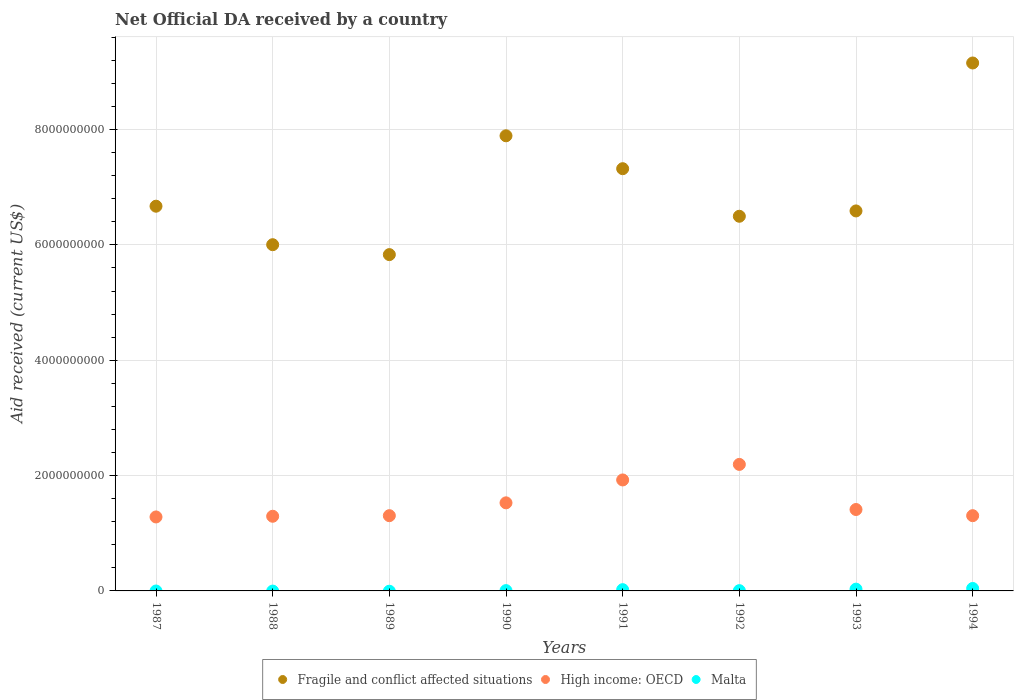What is the net official development assistance aid received in Fragile and conflict affected situations in 1990?
Give a very brief answer. 7.89e+09. Across all years, what is the maximum net official development assistance aid received in Fragile and conflict affected situations?
Offer a terse response. 9.16e+09. Across all years, what is the minimum net official development assistance aid received in Fragile and conflict affected situations?
Your answer should be compact. 5.83e+09. In which year was the net official development assistance aid received in High income: OECD maximum?
Give a very brief answer. 1992. What is the total net official development assistance aid received in Fragile and conflict affected situations in the graph?
Offer a very short reply. 5.60e+1. What is the difference between the net official development assistance aid received in High income: OECD in 1992 and that in 1993?
Offer a terse response. 7.82e+08. What is the difference between the net official development assistance aid received in Fragile and conflict affected situations in 1988 and the net official development assistance aid received in Malta in 1994?
Provide a short and direct response. 5.96e+09. What is the average net official development assistance aid received in Fragile and conflict affected situations per year?
Provide a short and direct response. 7.00e+09. In the year 1992, what is the difference between the net official development assistance aid received in High income: OECD and net official development assistance aid received in Fragile and conflict affected situations?
Give a very brief answer. -4.30e+09. What is the ratio of the net official development assistance aid received in High income: OECD in 1989 to that in 1992?
Ensure brevity in your answer.  0.59. Is the net official development assistance aid received in Fragile and conflict affected situations in 1991 less than that in 1993?
Make the answer very short. No. What is the difference between the highest and the second highest net official development assistance aid received in High income: OECD?
Make the answer very short. 2.70e+08. What is the difference between the highest and the lowest net official development assistance aid received in High income: OECD?
Ensure brevity in your answer.  9.11e+08. Is the sum of the net official development assistance aid received in High income: OECD in 1988 and 1992 greater than the maximum net official development assistance aid received in Fragile and conflict affected situations across all years?
Your response must be concise. No. Does the net official development assistance aid received in Fragile and conflict affected situations monotonically increase over the years?
Your answer should be very brief. No. How many years are there in the graph?
Your answer should be very brief. 8. What is the difference between two consecutive major ticks on the Y-axis?
Make the answer very short. 2.00e+09. Are the values on the major ticks of Y-axis written in scientific E-notation?
Make the answer very short. No. Does the graph contain any zero values?
Your response must be concise. Yes. How many legend labels are there?
Ensure brevity in your answer.  3. What is the title of the graph?
Offer a terse response. Net Official DA received by a country. Does "Brunei Darussalam" appear as one of the legend labels in the graph?
Your response must be concise. No. What is the label or title of the X-axis?
Make the answer very short. Years. What is the label or title of the Y-axis?
Offer a terse response. Aid received (current US$). What is the Aid received (current US$) of Fragile and conflict affected situations in 1987?
Make the answer very short. 6.67e+09. What is the Aid received (current US$) of High income: OECD in 1987?
Offer a very short reply. 1.28e+09. What is the Aid received (current US$) in Malta in 1987?
Give a very brief answer. 0. What is the Aid received (current US$) of Fragile and conflict affected situations in 1988?
Keep it short and to the point. 6.00e+09. What is the Aid received (current US$) in High income: OECD in 1988?
Keep it short and to the point. 1.29e+09. What is the Aid received (current US$) in Fragile and conflict affected situations in 1989?
Offer a very short reply. 5.83e+09. What is the Aid received (current US$) of High income: OECD in 1989?
Provide a short and direct response. 1.30e+09. What is the Aid received (current US$) of Malta in 1989?
Offer a terse response. 0. What is the Aid received (current US$) of Fragile and conflict affected situations in 1990?
Keep it short and to the point. 7.89e+09. What is the Aid received (current US$) in High income: OECD in 1990?
Provide a succinct answer. 1.53e+09. What is the Aid received (current US$) in Malta in 1990?
Your answer should be very brief. 5.31e+06. What is the Aid received (current US$) in Fragile and conflict affected situations in 1991?
Ensure brevity in your answer.  7.32e+09. What is the Aid received (current US$) in High income: OECD in 1991?
Ensure brevity in your answer.  1.92e+09. What is the Aid received (current US$) of Malta in 1991?
Ensure brevity in your answer.  2.18e+07. What is the Aid received (current US$) in Fragile and conflict affected situations in 1992?
Offer a very short reply. 6.50e+09. What is the Aid received (current US$) in High income: OECD in 1992?
Offer a very short reply. 2.19e+09. What is the Aid received (current US$) of Malta in 1992?
Your answer should be compact. 4.63e+06. What is the Aid received (current US$) in Fragile and conflict affected situations in 1993?
Your response must be concise. 6.59e+09. What is the Aid received (current US$) of High income: OECD in 1993?
Give a very brief answer. 1.41e+09. What is the Aid received (current US$) of Malta in 1993?
Your answer should be compact. 3.09e+07. What is the Aid received (current US$) of Fragile and conflict affected situations in 1994?
Offer a very short reply. 9.16e+09. What is the Aid received (current US$) in High income: OECD in 1994?
Provide a short and direct response. 1.30e+09. What is the Aid received (current US$) in Malta in 1994?
Give a very brief answer. 4.25e+07. Across all years, what is the maximum Aid received (current US$) in Fragile and conflict affected situations?
Provide a short and direct response. 9.16e+09. Across all years, what is the maximum Aid received (current US$) of High income: OECD?
Keep it short and to the point. 2.19e+09. Across all years, what is the maximum Aid received (current US$) in Malta?
Offer a terse response. 4.25e+07. Across all years, what is the minimum Aid received (current US$) in Fragile and conflict affected situations?
Ensure brevity in your answer.  5.83e+09. Across all years, what is the minimum Aid received (current US$) in High income: OECD?
Provide a succinct answer. 1.28e+09. What is the total Aid received (current US$) of Fragile and conflict affected situations in the graph?
Provide a short and direct response. 5.60e+1. What is the total Aid received (current US$) of High income: OECD in the graph?
Your answer should be compact. 1.22e+1. What is the total Aid received (current US$) of Malta in the graph?
Give a very brief answer. 1.05e+08. What is the difference between the Aid received (current US$) of Fragile and conflict affected situations in 1987 and that in 1988?
Provide a short and direct response. 6.68e+08. What is the difference between the Aid received (current US$) in High income: OECD in 1987 and that in 1988?
Your response must be concise. -1.19e+07. What is the difference between the Aid received (current US$) of Fragile and conflict affected situations in 1987 and that in 1989?
Ensure brevity in your answer.  8.40e+08. What is the difference between the Aid received (current US$) of High income: OECD in 1987 and that in 1989?
Give a very brief answer. -2.20e+07. What is the difference between the Aid received (current US$) of Fragile and conflict affected situations in 1987 and that in 1990?
Give a very brief answer. -1.22e+09. What is the difference between the Aid received (current US$) in High income: OECD in 1987 and that in 1990?
Your answer should be compact. -2.45e+08. What is the difference between the Aid received (current US$) of Fragile and conflict affected situations in 1987 and that in 1991?
Provide a short and direct response. -6.50e+08. What is the difference between the Aid received (current US$) of High income: OECD in 1987 and that in 1991?
Your answer should be very brief. -6.42e+08. What is the difference between the Aid received (current US$) of Fragile and conflict affected situations in 1987 and that in 1992?
Offer a very short reply. 1.75e+08. What is the difference between the Aid received (current US$) of High income: OECD in 1987 and that in 1992?
Offer a terse response. -9.11e+08. What is the difference between the Aid received (current US$) of Fragile and conflict affected situations in 1987 and that in 1993?
Your answer should be compact. 8.20e+07. What is the difference between the Aid received (current US$) of High income: OECD in 1987 and that in 1993?
Ensure brevity in your answer.  -1.29e+08. What is the difference between the Aid received (current US$) in Fragile and conflict affected situations in 1987 and that in 1994?
Ensure brevity in your answer.  -2.48e+09. What is the difference between the Aid received (current US$) of High income: OECD in 1987 and that in 1994?
Your response must be concise. -2.20e+07. What is the difference between the Aid received (current US$) of Fragile and conflict affected situations in 1988 and that in 1989?
Your answer should be very brief. 1.72e+08. What is the difference between the Aid received (current US$) in High income: OECD in 1988 and that in 1989?
Make the answer very short. -1.01e+07. What is the difference between the Aid received (current US$) of Fragile and conflict affected situations in 1988 and that in 1990?
Your answer should be very brief. -1.89e+09. What is the difference between the Aid received (current US$) of High income: OECD in 1988 and that in 1990?
Your answer should be compact. -2.33e+08. What is the difference between the Aid received (current US$) of Fragile and conflict affected situations in 1988 and that in 1991?
Keep it short and to the point. -1.32e+09. What is the difference between the Aid received (current US$) of High income: OECD in 1988 and that in 1991?
Provide a succinct answer. -6.30e+08. What is the difference between the Aid received (current US$) in Fragile and conflict affected situations in 1988 and that in 1992?
Offer a terse response. -4.93e+08. What is the difference between the Aid received (current US$) in High income: OECD in 1988 and that in 1992?
Keep it short and to the point. -8.99e+08. What is the difference between the Aid received (current US$) of Fragile and conflict affected situations in 1988 and that in 1993?
Provide a short and direct response. -5.86e+08. What is the difference between the Aid received (current US$) in High income: OECD in 1988 and that in 1993?
Keep it short and to the point. -1.17e+08. What is the difference between the Aid received (current US$) in Fragile and conflict affected situations in 1988 and that in 1994?
Keep it short and to the point. -3.15e+09. What is the difference between the Aid received (current US$) of High income: OECD in 1988 and that in 1994?
Offer a terse response. -1.02e+07. What is the difference between the Aid received (current US$) in Fragile and conflict affected situations in 1989 and that in 1990?
Offer a very short reply. -2.06e+09. What is the difference between the Aid received (current US$) in High income: OECD in 1989 and that in 1990?
Your answer should be very brief. -2.23e+08. What is the difference between the Aid received (current US$) in Fragile and conflict affected situations in 1989 and that in 1991?
Your answer should be compact. -1.49e+09. What is the difference between the Aid received (current US$) in High income: OECD in 1989 and that in 1991?
Give a very brief answer. -6.20e+08. What is the difference between the Aid received (current US$) in Fragile and conflict affected situations in 1989 and that in 1992?
Your answer should be compact. -6.65e+08. What is the difference between the Aid received (current US$) in High income: OECD in 1989 and that in 1992?
Give a very brief answer. -8.89e+08. What is the difference between the Aid received (current US$) of Fragile and conflict affected situations in 1989 and that in 1993?
Your answer should be very brief. -7.58e+08. What is the difference between the Aid received (current US$) of High income: OECD in 1989 and that in 1993?
Offer a very short reply. -1.07e+08. What is the difference between the Aid received (current US$) in Fragile and conflict affected situations in 1989 and that in 1994?
Keep it short and to the point. -3.32e+09. What is the difference between the Aid received (current US$) in Fragile and conflict affected situations in 1990 and that in 1991?
Offer a terse response. 5.70e+08. What is the difference between the Aid received (current US$) of High income: OECD in 1990 and that in 1991?
Keep it short and to the point. -3.97e+08. What is the difference between the Aid received (current US$) of Malta in 1990 and that in 1991?
Keep it short and to the point. -1.65e+07. What is the difference between the Aid received (current US$) in Fragile and conflict affected situations in 1990 and that in 1992?
Keep it short and to the point. 1.40e+09. What is the difference between the Aid received (current US$) in High income: OECD in 1990 and that in 1992?
Your answer should be very brief. -6.67e+08. What is the difference between the Aid received (current US$) of Malta in 1990 and that in 1992?
Make the answer very short. 6.80e+05. What is the difference between the Aid received (current US$) in Fragile and conflict affected situations in 1990 and that in 1993?
Keep it short and to the point. 1.30e+09. What is the difference between the Aid received (current US$) of High income: OECD in 1990 and that in 1993?
Provide a short and direct response. 1.16e+08. What is the difference between the Aid received (current US$) of Malta in 1990 and that in 1993?
Offer a terse response. -2.56e+07. What is the difference between the Aid received (current US$) of Fragile and conflict affected situations in 1990 and that in 1994?
Ensure brevity in your answer.  -1.26e+09. What is the difference between the Aid received (current US$) of High income: OECD in 1990 and that in 1994?
Give a very brief answer. 2.23e+08. What is the difference between the Aid received (current US$) of Malta in 1990 and that in 1994?
Make the answer very short. -3.72e+07. What is the difference between the Aid received (current US$) in Fragile and conflict affected situations in 1991 and that in 1992?
Offer a very short reply. 8.25e+08. What is the difference between the Aid received (current US$) of High income: OECD in 1991 and that in 1992?
Make the answer very short. -2.70e+08. What is the difference between the Aid received (current US$) in Malta in 1991 and that in 1992?
Keep it short and to the point. 1.72e+07. What is the difference between the Aid received (current US$) in Fragile and conflict affected situations in 1991 and that in 1993?
Your answer should be very brief. 7.32e+08. What is the difference between the Aid received (current US$) in High income: OECD in 1991 and that in 1993?
Keep it short and to the point. 5.13e+08. What is the difference between the Aid received (current US$) in Malta in 1991 and that in 1993?
Keep it short and to the point. -9.07e+06. What is the difference between the Aid received (current US$) of Fragile and conflict affected situations in 1991 and that in 1994?
Make the answer very short. -1.83e+09. What is the difference between the Aid received (current US$) of High income: OECD in 1991 and that in 1994?
Offer a terse response. 6.20e+08. What is the difference between the Aid received (current US$) of Malta in 1991 and that in 1994?
Make the answer very short. -2.07e+07. What is the difference between the Aid received (current US$) in Fragile and conflict affected situations in 1992 and that in 1993?
Offer a very short reply. -9.26e+07. What is the difference between the Aid received (current US$) of High income: OECD in 1992 and that in 1993?
Ensure brevity in your answer.  7.82e+08. What is the difference between the Aid received (current US$) in Malta in 1992 and that in 1993?
Your response must be concise. -2.62e+07. What is the difference between the Aid received (current US$) in Fragile and conflict affected situations in 1992 and that in 1994?
Your answer should be compact. -2.66e+09. What is the difference between the Aid received (current US$) of High income: OECD in 1992 and that in 1994?
Ensure brevity in your answer.  8.89e+08. What is the difference between the Aid received (current US$) of Malta in 1992 and that in 1994?
Offer a terse response. -3.79e+07. What is the difference between the Aid received (current US$) of Fragile and conflict affected situations in 1993 and that in 1994?
Offer a terse response. -2.57e+09. What is the difference between the Aid received (current US$) in High income: OECD in 1993 and that in 1994?
Offer a terse response. 1.07e+08. What is the difference between the Aid received (current US$) in Malta in 1993 and that in 1994?
Your response must be concise. -1.16e+07. What is the difference between the Aid received (current US$) in Fragile and conflict affected situations in 1987 and the Aid received (current US$) in High income: OECD in 1988?
Provide a succinct answer. 5.38e+09. What is the difference between the Aid received (current US$) of Fragile and conflict affected situations in 1987 and the Aid received (current US$) of High income: OECD in 1989?
Keep it short and to the point. 5.37e+09. What is the difference between the Aid received (current US$) in Fragile and conflict affected situations in 1987 and the Aid received (current US$) in High income: OECD in 1990?
Ensure brevity in your answer.  5.14e+09. What is the difference between the Aid received (current US$) in Fragile and conflict affected situations in 1987 and the Aid received (current US$) in Malta in 1990?
Your response must be concise. 6.67e+09. What is the difference between the Aid received (current US$) of High income: OECD in 1987 and the Aid received (current US$) of Malta in 1990?
Your answer should be very brief. 1.28e+09. What is the difference between the Aid received (current US$) of Fragile and conflict affected situations in 1987 and the Aid received (current US$) of High income: OECD in 1991?
Make the answer very short. 4.75e+09. What is the difference between the Aid received (current US$) of Fragile and conflict affected situations in 1987 and the Aid received (current US$) of Malta in 1991?
Your answer should be compact. 6.65e+09. What is the difference between the Aid received (current US$) in High income: OECD in 1987 and the Aid received (current US$) in Malta in 1991?
Your response must be concise. 1.26e+09. What is the difference between the Aid received (current US$) of Fragile and conflict affected situations in 1987 and the Aid received (current US$) of High income: OECD in 1992?
Ensure brevity in your answer.  4.48e+09. What is the difference between the Aid received (current US$) in Fragile and conflict affected situations in 1987 and the Aid received (current US$) in Malta in 1992?
Offer a very short reply. 6.67e+09. What is the difference between the Aid received (current US$) of High income: OECD in 1987 and the Aid received (current US$) of Malta in 1992?
Give a very brief answer. 1.28e+09. What is the difference between the Aid received (current US$) in Fragile and conflict affected situations in 1987 and the Aid received (current US$) in High income: OECD in 1993?
Give a very brief answer. 5.26e+09. What is the difference between the Aid received (current US$) in Fragile and conflict affected situations in 1987 and the Aid received (current US$) in Malta in 1993?
Offer a very short reply. 6.64e+09. What is the difference between the Aid received (current US$) of High income: OECD in 1987 and the Aid received (current US$) of Malta in 1993?
Ensure brevity in your answer.  1.25e+09. What is the difference between the Aid received (current US$) of Fragile and conflict affected situations in 1987 and the Aid received (current US$) of High income: OECD in 1994?
Offer a terse response. 5.37e+09. What is the difference between the Aid received (current US$) of Fragile and conflict affected situations in 1987 and the Aid received (current US$) of Malta in 1994?
Your response must be concise. 6.63e+09. What is the difference between the Aid received (current US$) in High income: OECD in 1987 and the Aid received (current US$) in Malta in 1994?
Provide a succinct answer. 1.24e+09. What is the difference between the Aid received (current US$) in Fragile and conflict affected situations in 1988 and the Aid received (current US$) in High income: OECD in 1989?
Give a very brief answer. 4.70e+09. What is the difference between the Aid received (current US$) in Fragile and conflict affected situations in 1988 and the Aid received (current US$) in High income: OECD in 1990?
Offer a very short reply. 4.48e+09. What is the difference between the Aid received (current US$) of Fragile and conflict affected situations in 1988 and the Aid received (current US$) of Malta in 1990?
Make the answer very short. 6.00e+09. What is the difference between the Aid received (current US$) of High income: OECD in 1988 and the Aid received (current US$) of Malta in 1990?
Keep it short and to the point. 1.29e+09. What is the difference between the Aid received (current US$) of Fragile and conflict affected situations in 1988 and the Aid received (current US$) of High income: OECD in 1991?
Offer a terse response. 4.08e+09. What is the difference between the Aid received (current US$) of Fragile and conflict affected situations in 1988 and the Aid received (current US$) of Malta in 1991?
Provide a succinct answer. 5.98e+09. What is the difference between the Aid received (current US$) in High income: OECD in 1988 and the Aid received (current US$) in Malta in 1991?
Your answer should be very brief. 1.27e+09. What is the difference between the Aid received (current US$) in Fragile and conflict affected situations in 1988 and the Aid received (current US$) in High income: OECD in 1992?
Keep it short and to the point. 3.81e+09. What is the difference between the Aid received (current US$) of Fragile and conflict affected situations in 1988 and the Aid received (current US$) of Malta in 1992?
Your answer should be compact. 6.00e+09. What is the difference between the Aid received (current US$) in High income: OECD in 1988 and the Aid received (current US$) in Malta in 1992?
Your answer should be compact. 1.29e+09. What is the difference between the Aid received (current US$) of Fragile and conflict affected situations in 1988 and the Aid received (current US$) of High income: OECD in 1993?
Your answer should be compact. 4.59e+09. What is the difference between the Aid received (current US$) of Fragile and conflict affected situations in 1988 and the Aid received (current US$) of Malta in 1993?
Provide a short and direct response. 5.97e+09. What is the difference between the Aid received (current US$) of High income: OECD in 1988 and the Aid received (current US$) of Malta in 1993?
Your response must be concise. 1.26e+09. What is the difference between the Aid received (current US$) of Fragile and conflict affected situations in 1988 and the Aid received (current US$) of High income: OECD in 1994?
Make the answer very short. 4.70e+09. What is the difference between the Aid received (current US$) in Fragile and conflict affected situations in 1988 and the Aid received (current US$) in Malta in 1994?
Provide a succinct answer. 5.96e+09. What is the difference between the Aid received (current US$) of High income: OECD in 1988 and the Aid received (current US$) of Malta in 1994?
Your answer should be very brief. 1.25e+09. What is the difference between the Aid received (current US$) of Fragile and conflict affected situations in 1989 and the Aid received (current US$) of High income: OECD in 1990?
Provide a succinct answer. 4.30e+09. What is the difference between the Aid received (current US$) in Fragile and conflict affected situations in 1989 and the Aid received (current US$) in Malta in 1990?
Your response must be concise. 5.83e+09. What is the difference between the Aid received (current US$) in High income: OECD in 1989 and the Aid received (current US$) in Malta in 1990?
Provide a short and direct response. 1.30e+09. What is the difference between the Aid received (current US$) in Fragile and conflict affected situations in 1989 and the Aid received (current US$) in High income: OECD in 1991?
Give a very brief answer. 3.91e+09. What is the difference between the Aid received (current US$) of Fragile and conflict affected situations in 1989 and the Aid received (current US$) of Malta in 1991?
Make the answer very short. 5.81e+09. What is the difference between the Aid received (current US$) in High income: OECD in 1989 and the Aid received (current US$) in Malta in 1991?
Provide a short and direct response. 1.28e+09. What is the difference between the Aid received (current US$) in Fragile and conflict affected situations in 1989 and the Aid received (current US$) in High income: OECD in 1992?
Your response must be concise. 3.64e+09. What is the difference between the Aid received (current US$) of Fragile and conflict affected situations in 1989 and the Aid received (current US$) of Malta in 1992?
Your answer should be compact. 5.83e+09. What is the difference between the Aid received (current US$) of High income: OECD in 1989 and the Aid received (current US$) of Malta in 1992?
Give a very brief answer. 1.30e+09. What is the difference between the Aid received (current US$) of Fragile and conflict affected situations in 1989 and the Aid received (current US$) of High income: OECD in 1993?
Provide a short and direct response. 4.42e+09. What is the difference between the Aid received (current US$) of Fragile and conflict affected situations in 1989 and the Aid received (current US$) of Malta in 1993?
Make the answer very short. 5.80e+09. What is the difference between the Aid received (current US$) of High income: OECD in 1989 and the Aid received (current US$) of Malta in 1993?
Your answer should be very brief. 1.27e+09. What is the difference between the Aid received (current US$) in Fragile and conflict affected situations in 1989 and the Aid received (current US$) in High income: OECD in 1994?
Your response must be concise. 4.53e+09. What is the difference between the Aid received (current US$) of Fragile and conflict affected situations in 1989 and the Aid received (current US$) of Malta in 1994?
Keep it short and to the point. 5.79e+09. What is the difference between the Aid received (current US$) in High income: OECD in 1989 and the Aid received (current US$) in Malta in 1994?
Give a very brief answer. 1.26e+09. What is the difference between the Aid received (current US$) in Fragile and conflict affected situations in 1990 and the Aid received (current US$) in High income: OECD in 1991?
Offer a terse response. 5.97e+09. What is the difference between the Aid received (current US$) in Fragile and conflict affected situations in 1990 and the Aid received (current US$) in Malta in 1991?
Your answer should be compact. 7.87e+09. What is the difference between the Aid received (current US$) of High income: OECD in 1990 and the Aid received (current US$) of Malta in 1991?
Your answer should be compact. 1.51e+09. What is the difference between the Aid received (current US$) in Fragile and conflict affected situations in 1990 and the Aid received (current US$) in High income: OECD in 1992?
Offer a terse response. 5.70e+09. What is the difference between the Aid received (current US$) of Fragile and conflict affected situations in 1990 and the Aid received (current US$) of Malta in 1992?
Provide a succinct answer. 7.89e+09. What is the difference between the Aid received (current US$) of High income: OECD in 1990 and the Aid received (current US$) of Malta in 1992?
Offer a very short reply. 1.52e+09. What is the difference between the Aid received (current US$) of Fragile and conflict affected situations in 1990 and the Aid received (current US$) of High income: OECD in 1993?
Provide a succinct answer. 6.48e+09. What is the difference between the Aid received (current US$) in Fragile and conflict affected situations in 1990 and the Aid received (current US$) in Malta in 1993?
Offer a very short reply. 7.86e+09. What is the difference between the Aid received (current US$) in High income: OECD in 1990 and the Aid received (current US$) in Malta in 1993?
Make the answer very short. 1.50e+09. What is the difference between the Aid received (current US$) of Fragile and conflict affected situations in 1990 and the Aid received (current US$) of High income: OECD in 1994?
Your answer should be compact. 6.59e+09. What is the difference between the Aid received (current US$) of Fragile and conflict affected situations in 1990 and the Aid received (current US$) of Malta in 1994?
Provide a short and direct response. 7.85e+09. What is the difference between the Aid received (current US$) in High income: OECD in 1990 and the Aid received (current US$) in Malta in 1994?
Offer a terse response. 1.48e+09. What is the difference between the Aid received (current US$) in Fragile and conflict affected situations in 1991 and the Aid received (current US$) in High income: OECD in 1992?
Provide a short and direct response. 5.13e+09. What is the difference between the Aid received (current US$) of Fragile and conflict affected situations in 1991 and the Aid received (current US$) of Malta in 1992?
Your answer should be very brief. 7.32e+09. What is the difference between the Aid received (current US$) of High income: OECD in 1991 and the Aid received (current US$) of Malta in 1992?
Your answer should be very brief. 1.92e+09. What is the difference between the Aid received (current US$) of Fragile and conflict affected situations in 1991 and the Aid received (current US$) of High income: OECD in 1993?
Your answer should be compact. 5.91e+09. What is the difference between the Aid received (current US$) of Fragile and conflict affected situations in 1991 and the Aid received (current US$) of Malta in 1993?
Offer a very short reply. 7.29e+09. What is the difference between the Aid received (current US$) of High income: OECD in 1991 and the Aid received (current US$) of Malta in 1993?
Offer a terse response. 1.89e+09. What is the difference between the Aid received (current US$) in Fragile and conflict affected situations in 1991 and the Aid received (current US$) in High income: OECD in 1994?
Offer a terse response. 6.02e+09. What is the difference between the Aid received (current US$) in Fragile and conflict affected situations in 1991 and the Aid received (current US$) in Malta in 1994?
Your answer should be very brief. 7.28e+09. What is the difference between the Aid received (current US$) in High income: OECD in 1991 and the Aid received (current US$) in Malta in 1994?
Ensure brevity in your answer.  1.88e+09. What is the difference between the Aid received (current US$) of Fragile and conflict affected situations in 1992 and the Aid received (current US$) of High income: OECD in 1993?
Keep it short and to the point. 5.09e+09. What is the difference between the Aid received (current US$) of Fragile and conflict affected situations in 1992 and the Aid received (current US$) of Malta in 1993?
Your answer should be compact. 6.47e+09. What is the difference between the Aid received (current US$) of High income: OECD in 1992 and the Aid received (current US$) of Malta in 1993?
Offer a very short reply. 2.16e+09. What is the difference between the Aid received (current US$) of Fragile and conflict affected situations in 1992 and the Aid received (current US$) of High income: OECD in 1994?
Ensure brevity in your answer.  5.19e+09. What is the difference between the Aid received (current US$) of Fragile and conflict affected situations in 1992 and the Aid received (current US$) of Malta in 1994?
Provide a short and direct response. 6.45e+09. What is the difference between the Aid received (current US$) in High income: OECD in 1992 and the Aid received (current US$) in Malta in 1994?
Your answer should be very brief. 2.15e+09. What is the difference between the Aid received (current US$) in Fragile and conflict affected situations in 1993 and the Aid received (current US$) in High income: OECD in 1994?
Your answer should be very brief. 5.28e+09. What is the difference between the Aid received (current US$) of Fragile and conflict affected situations in 1993 and the Aid received (current US$) of Malta in 1994?
Keep it short and to the point. 6.55e+09. What is the difference between the Aid received (current US$) in High income: OECD in 1993 and the Aid received (current US$) in Malta in 1994?
Ensure brevity in your answer.  1.37e+09. What is the average Aid received (current US$) in Fragile and conflict affected situations per year?
Ensure brevity in your answer.  7.00e+09. What is the average Aid received (current US$) of High income: OECD per year?
Offer a terse response. 1.53e+09. What is the average Aid received (current US$) in Malta per year?
Ensure brevity in your answer.  1.31e+07. In the year 1987, what is the difference between the Aid received (current US$) in Fragile and conflict affected situations and Aid received (current US$) in High income: OECD?
Your response must be concise. 5.39e+09. In the year 1988, what is the difference between the Aid received (current US$) in Fragile and conflict affected situations and Aid received (current US$) in High income: OECD?
Your answer should be very brief. 4.71e+09. In the year 1989, what is the difference between the Aid received (current US$) of Fragile and conflict affected situations and Aid received (current US$) of High income: OECD?
Offer a terse response. 4.53e+09. In the year 1990, what is the difference between the Aid received (current US$) in Fragile and conflict affected situations and Aid received (current US$) in High income: OECD?
Your response must be concise. 6.37e+09. In the year 1990, what is the difference between the Aid received (current US$) in Fragile and conflict affected situations and Aid received (current US$) in Malta?
Your response must be concise. 7.89e+09. In the year 1990, what is the difference between the Aid received (current US$) in High income: OECD and Aid received (current US$) in Malta?
Ensure brevity in your answer.  1.52e+09. In the year 1991, what is the difference between the Aid received (current US$) in Fragile and conflict affected situations and Aid received (current US$) in High income: OECD?
Provide a succinct answer. 5.40e+09. In the year 1991, what is the difference between the Aid received (current US$) in Fragile and conflict affected situations and Aid received (current US$) in Malta?
Your response must be concise. 7.30e+09. In the year 1991, what is the difference between the Aid received (current US$) of High income: OECD and Aid received (current US$) of Malta?
Give a very brief answer. 1.90e+09. In the year 1992, what is the difference between the Aid received (current US$) of Fragile and conflict affected situations and Aid received (current US$) of High income: OECD?
Keep it short and to the point. 4.30e+09. In the year 1992, what is the difference between the Aid received (current US$) in Fragile and conflict affected situations and Aid received (current US$) in Malta?
Your response must be concise. 6.49e+09. In the year 1992, what is the difference between the Aid received (current US$) of High income: OECD and Aid received (current US$) of Malta?
Your answer should be compact. 2.19e+09. In the year 1993, what is the difference between the Aid received (current US$) of Fragile and conflict affected situations and Aid received (current US$) of High income: OECD?
Ensure brevity in your answer.  5.18e+09. In the year 1993, what is the difference between the Aid received (current US$) of Fragile and conflict affected situations and Aid received (current US$) of Malta?
Give a very brief answer. 6.56e+09. In the year 1993, what is the difference between the Aid received (current US$) in High income: OECD and Aid received (current US$) in Malta?
Offer a very short reply. 1.38e+09. In the year 1994, what is the difference between the Aid received (current US$) of Fragile and conflict affected situations and Aid received (current US$) of High income: OECD?
Provide a short and direct response. 7.85e+09. In the year 1994, what is the difference between the Aid received (current US$) in Fragile and conflict affected situations and Aid received (current US$) in Malta?
Provide a short and direct response. 9.11e+09. In the year 1994, what is the difference between the Aid received (current US$) in High income: OECD and Aid received (current US$) in Malta?
Provide a short and direct response. 1.26e+09. What is the ratio of the Aid received (current US$) of Fragile and conflict affected situations in 1987 to that in 1988?
Keep it short and to the point. 1.11. What is the ratio of the Aid received (current US$) in Fragile and conflict affected situations in 1987 to that in 1989?
Keep it short and to the point. 1.14. What is the ratio of the Aid received (current US$) of High income: OECD in 1987 to that in 1989?
Your answer should be compact. 0.98. What is the ratio of the Aid received (current US$) of Fragile and conflict affected situations in 1987 to that in 1990?
Keep it short and to the point. 0.85. What is the ratio of the Aid received (current US$) in High income: OECD in 1987 to that in 1990?
Offer a very short reply. 0.84. What is the ratio of the Aid received (current US$) of Fragile and conflict affected situations in 1987 to that in 1991?
Keep it short and to the point. 0.91. What is the ratio of the Aid received (current US$) in High income: OECD in 1987 to that in 1991?
Your answer should be compact. 0.67. What is the ratio of the Aid received (current US$) in Fragile and conflict affected situations in 1987 to that in 1992?
Make the answer very short. 1.03. What is the ratio of the Aid received (current US$) of High income: OECD in 1987 to that in 1992?
Your answer should be very brief. 0.58. What is the ratio of the Aid received (current US$) of Fragile and conflict affected situations in 1987 to that in 1993?
Your answer should be compact. 1.01. What is the ratio of the Aid received (current US$) of High income: OECD in 1987 to that in 1993?
Provide a succinct answer. 0.91. What is the ratio of the Aid received (current US$) of Fragile and conflict affected situations in 1987 to that in 1994?
Give a very brief answer. 0.73. What is the ratio of the Aid received (current US$) of High income: OECD in 1987 to that in 1994?
Offer a terse response. 0.98. What is the ratio of the Aid received (current US$) in Fragile and conflict affected situations in 1988 to that in 1989?
Give a very brief answer. 1.03. What is the ratio of the Aid received (current US$) in High income: OECD in 1988 to that in 1989?
Your answer should be very brief. 0.99. What is the ratio of the Aid received (current US$) of Fragile and conflict affected situations in 1988 to that in 1990?
Ensure brevity in your answer.  0.76. What is the ratio of the Aid received (current US$) in High income: OECD in 1988 to that in 1990?
Provide a short and direct response. 0.85. What is the ratio of the Aid received (current US$) in Fragile and conflict affected situations in 1988 to that in 1991?
Give a very brief answer. 0.82. What is the ratio of the Aid received (current US$) in High income: OECD in 1988 to that in 1991?
Provide a succinct answer. 0.67. What is the ratio of the Aid received (current US$) of Fragile and conflict affected situations in 1988 to that in 1992?
Offer a terse response. 0.92. What is the ratio of the Aid received (current US$) in High income: OECD in 1988 to that in 1992?
Your answer should be very brief. 0.59. What is the ratio of the Aid received (current US$) of Fragile and conflict affected situations in 1988 to that in 1993?
Your answer should be very brief. 0.91. What is the ratio of the Aid received (current US$) of High income: OECD in 1988 to that in 1993?
Your response must be concise. 0.92. What is the ratio of the Aid received (current US$) in Fragile and conflict affected situations in 1988 to that in 1994?
Your response must be concise. 0.66. What is the ratio of the Aid received (current US$) in High income: OECD in 1988 to that in 1994?
Your answer should be compact. 0.99. What is the ratio of the Aid received (current US$) of Fragile and conflict affected situations in 1989 to that in 1990?
Offer a very short reply. 0.74. What is the ratio of the Aid received (current US$) in High income: OECD in 1989 to that in 1990?
Offer a very short reply. 0.85. What is the ratio of the Aid received (current US$) in Fragile and conflict affected situations in 1989 to that in 1991?
Offer a very short reply. 0.8. What is the ratio of the Aid received (current US$) in High income: OECD in 1989 to that in 1991?
Offer a very short reply. 0.68. What is the ratio of the Aid received (current US$) in Fragile and conflict affected situations in 1989 to that in 1992?
Your response must be concise. 0.9. What is the ratio of the Aid received (current US$) in High income: OECD in 1989 to that in 1992?
Offer a very short reply. 0.59. What is the ratio of the Aid received (current US$) of Fragile and conflict affected situations in 1989 to that in 1993?
Keep it short and to the point. 0.89. What is the ratio of the Aid received (current US$) of High income: OECD in 1989 to that in 1993?
Your response must be concise. 0.92. What is the ratio of the Aid received (current US$) in Fragile and conflict affected situations in 1989 to that in 1994?
Provide a short and direct response. 0.64. What is the ratio of the Aid received (current US$) in High income: OECD in 1989 to that in 1994?
Give a very brief answer. 1. What is the ratio of the Aid received (current US$) in Fragile and conflict affected situations in 1990 to that in 1991?
Your answer should be very brief. 1.08. What is the ratio of the Aid received (current US$) in High income: OECD in 1990 to that in 1991?
Your answer should be very brief. 0.79. What is the ratio of the Aid received (current US$) in Malta in 1990 to that in 1991?
Provide a short and direct response. 0.24. What is the ratio of the Aid received (current US$) of Fragile and conflict affected situations in 1990 to that in 1992?
Provide a succinct answer. 1.21. What is the ratio of the Aid received (current US$) in High income: OECD in 1990 to that in 1992?
Ensure brevity in your answer.  0.7. What is the ratio of the Aid received (current US$) in Malta in 1990 to that in 1992?
Your response must be concise. 1.15. What is the ratio of the Aid received (current US$) of Fragile and conflict affected situations in 1990 to that in 1993?
Offer a very short reply. 1.2. What is the ratio of the Aid received (current US$) in High income: OECD in 1990 to that in 1993?
Your answer should be very brief. 1.08. What is the ratio of the Aid received (current US$) of Malta in 1990 to that in 1993?
Provide a succinct answer. 0.17. What is the ratio of the Aid received (current US$) in Fragile and conflict affected situations in 1990 to that in 1994?
Offer a terse response. 0.86. What is the ratio of the Aid received (current US$) in High income: OECD in 1990 to that in 1994?
Make the answer very short. 1.17. What is the ratio of the Aid received (current US$) of Malta in 1990 to that in 1994?
Your response must be concise. 0.12. What is the ratio of the Aid received (current US$) in Fragile and conflict affected situations in 1991 to that in 1992?
Your answer should be compact. 1.13. What is the ratio of the Aid received (current US$) in High income: OECD in 1991 to that in 1992?
Provide a succinct answer. 0.88. What is the ratio of the Aid received (current US$) in Malta in 1991 to that in 1992?
Provide a short and direct response. 4.71. What is the ratio of the Aid received (current US$) in High income: OECD in 1991 to that in 1993?
Your response must be concise. 1.36. What is the ratio of the Aid received (current US$) of Malta in 1991 to that in 1993?
Offer a very short reply. 0.71. What is the ratio of the Aid received (current US$) of Fragile and conflict affected situations in 1991 to that in 1994?
Provide a short and direct response. 0.8. What is the ratio of the Aid received (current US$) in High income: OECD in 1991 to that in 1994?
Keep it short and to the point. 1.47. What is the ratio of the Aid received (current US$) of Malta in 1991 to that in 1994?
Provide a short and direct response. 0.51. What is the ratio of the Aid received (current US$) in Fragile and conflict affected situations in 1992 to that in 1993?
Make the answer very short. 0.99. What is the ratio of the Aid received (current US$) of High income: OECD in 1992 to that in 1993?
Offer a very short reply. 1.55. What is the ratio of the Aid received (current US$) in Fragile and conflict affected situations in 1992 to that in 1994?
Make the answer very short. 0.71. What is the ratio of the Aid received (current US$) of High income: OECD in 1992 to that in 1994?
Offer a very short reply. 1.68. What is the ratio of the Aid received (current US$) of Malta in 1992 to that in 1994?
Ensure brevity in your answer.  0.11. What is the ratio of the Aid received (current US$) of Fragile and conflict affected situations in 1993 to that in 1994?
Provide a short and direct response. 0.72. What is the ratio of the Aid received (current US$) of High income: OECD in 1993 to that in 1994?
Give a very brief answer. 1.08. What is the ratio of the Aid received (current US$) of Malta in 1993 to that in 1994?
Give a very brief answer. 0.73. What is the difference between the highest and the second highest Aid received (current US$) of Fragile and conflict affected situations?
Offer a very short reply. 1.26e+09. What is the difference between the highest and the second highest Aid received (current US$) in High income: OECD?
Make the answer very short. 2.70e+08. What is the difference between the highest and the second highest Aid received (current US$) in Malta?
Provide a succinct answer. 1.16e+07. What is the difference between the highest and the lowest Aid received (current US$) in Fragile and conflict affected situations?
Provide a short and direct response. 3.32e+09. What is the difference between the highest and the lowest Aid received (current US$) of High income: OECD?
Provide a succinct answer. 9.11e+08. What is the difference between the highest and the lowest Aid received (current US$) in Malta?
Offer a terse response. 4.25e+07. 